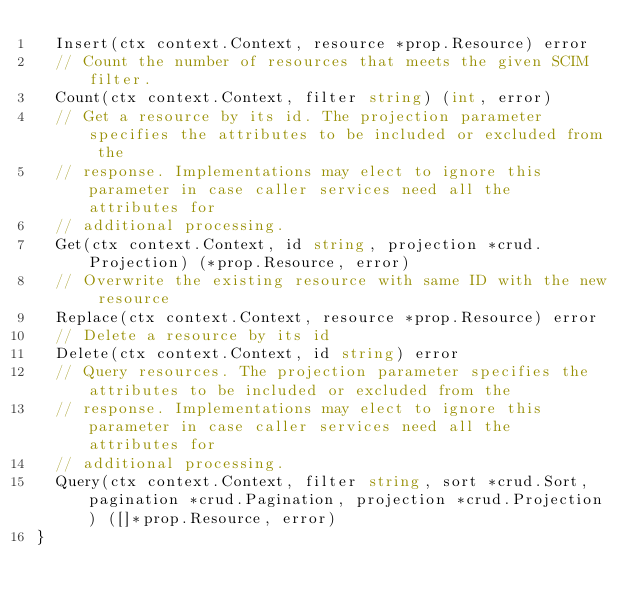Convert code to text. <code><loc_0><loc_0><loc_500><loc_500><_Go_>	Insert(ctx context.Context, resource *prop.Resource) error
	// Count the number of resources that meets the given SCIM filter.
	Count(ctx context.Context, filter string) (int, error)
	// Get a resource by its id. The projection parameter specifies the attributes to be included or excluded from the
	// response. Implementations may elect to ignore this parameter in case caller services need all the attributes for
	// additional processing.
	Get(ctx context.Context, id string, projection *crud.Projection) (*prop.Resource, error)
	// Overwrite the existing resource with same ID with the new resource
	Replace(ctx context.Context, resource *prop.Resource) error
	// Delete a resource by its id
	Delete(ctx context.Context, id string) error
	// Query resources. The projection parameter specifies the attributes to be included or excluded from the
	// response. Implementations may elect to ignore this parameter in case caller services need all the attributes for
	// additional processing.
	Query(ctx context.Context, filter string, sort *crud.Sort, pagination *crud.Pagination, projection *crud.Projection) ([]*prop.Resource, error)
}
</code> 